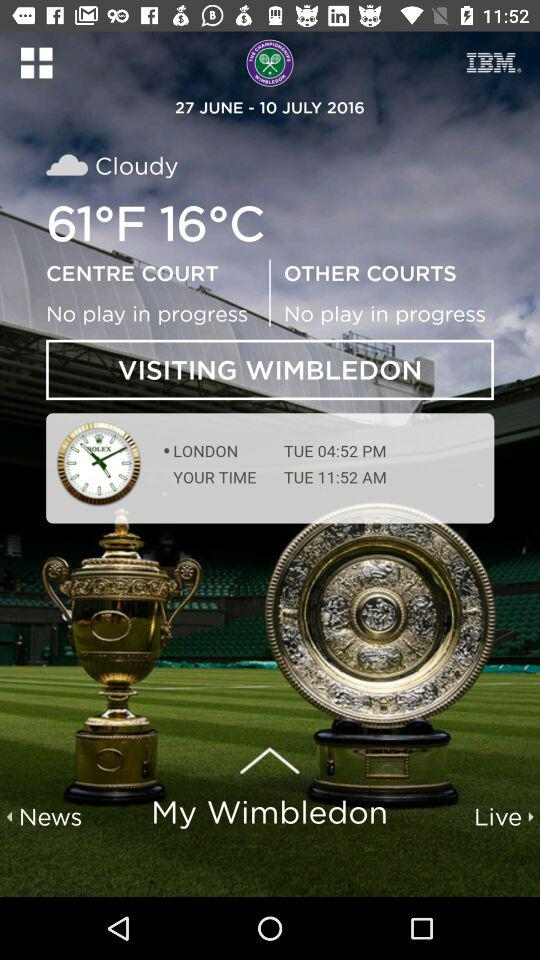What is London time? The London time is 04:52 PM. 